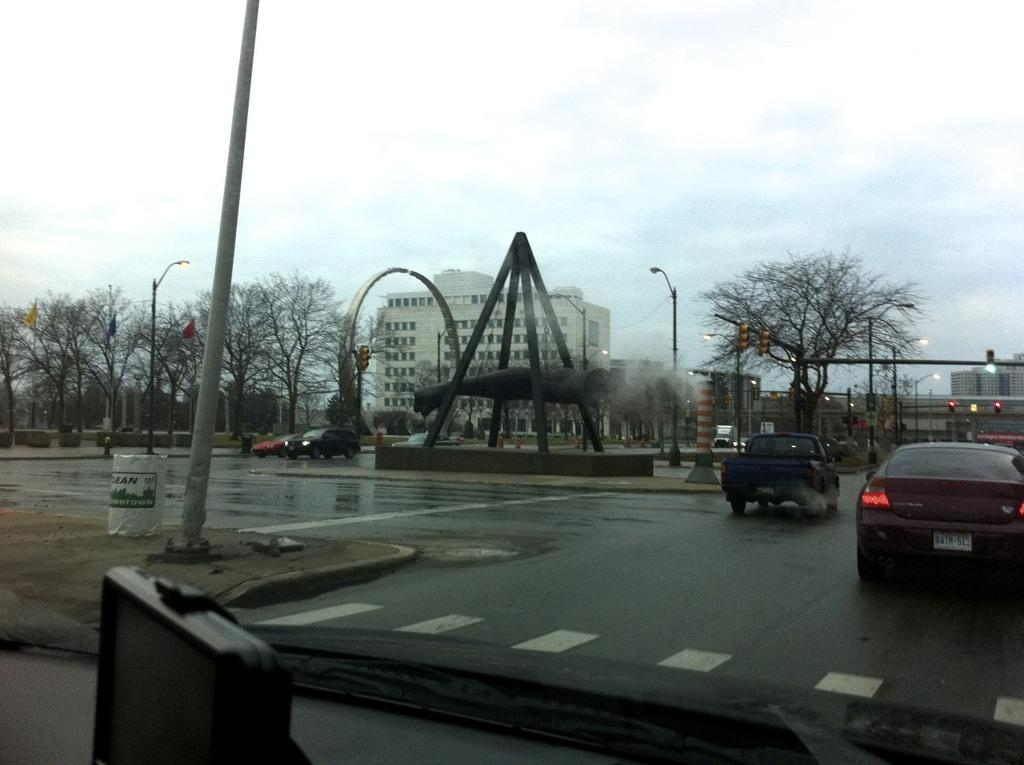What type of view is shown in the image? The image is an outside view. What can be seen on the road in the image? There are cars on the road. What is visible in the background of the image? There are trees, poles, street lights, and buildings in the background. What part of the natural environment is visible in the image? The sky is visible at the top of the image. What type of ant can be seen crawling on the steel pole in the image? There is no ant or steel pole present in the image. Who is the owner of the buildings in the image? The image does not provide information about the ownership of the buildings. 